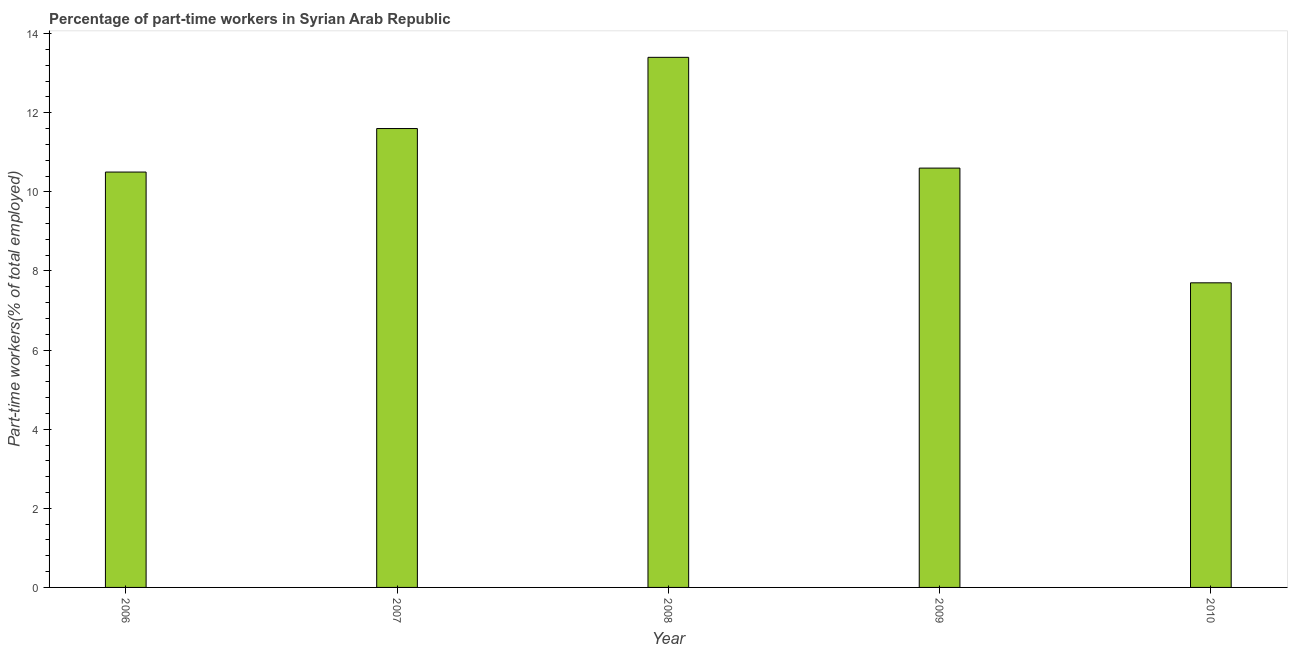Does the graph contain any zero values?
Provide a short and direct response. No. What is the title of the graph?
Give a very brief answer. Percentage of part-time workers in Syrian Arab Republic. What is the label or title of the X-axis?
Provide a short and direct response. Year. What is the label or title of the Y-axis?
Provide a succinct answer. Part-time workers(% of total employed). What is the percentage of part-time workers in 2010?
Offer a very short reply. 7.7. Across all years, what is the maximum percentage of part-time workers?
Offer a very short reply. 13.4. Across all years, what is the minimum percentage of part-time workers?
Offer a terse response. 7.7. In which year was the percentage of part-time workers maximum?
Provide a succinct answer. 2008. What is the sum of the percentage of part-time workers?
Offer a terse response. 53.8. What is the difference between the percentage of part-time workers in 2006 and 2009?
Your answer should be compact. -0.1. What is the average percentage of part-time workers per year?
Make the answer very short. 10.76. What is the median percentage of part-time workers?
Keep it short and to the point. 10.6. In how many years, is the percentage of part-time workers greater than 1.2 %?
Your answer should be compact. 5. What is the ratio of the percentage of part-time workers in 2006 to that in 2007?
Keep it short and to the point. 0.91. Is the difference between the percentage of part-time workers in 2008 and 2009 greater than the difference between any two years?
Your answer should be compact. No. In how many years, is the percentage of part-time workers greater than the average percentage of part-time workers taken over all years?
Your answer should be very brief. 2. Are all the bars in the graph horizontal?
Your answer should be compact. No. How many years are there in the graph?
Make the answer very short. 5. Are the values on the major ticks of Y-axis written in scientific E-notation?
Provide a short and direct response. No. What is the Part-time workers(% of total employed) of 2007?
Give a very brief answer. 11.6. What is the Part-time workers(% of total employed) in 2008?
Give a very brief answer. 13.4. What is the Part-time workers(% of total employed) of 2009?
Provide a short and direct response. 10.6. What is the Part-time workers(% of total employed) of 2010?
Your answer should be very brief. 7.7. What is the difference between the Part-time workers(% of total employed) in 2006 and 2007?
Your answer should be compact. -1.1. What is the difference between the Part-time workers(% of total employed) in 2006 and 2010?
Provide a succinct answer. 2.8. What is the difference between the Part-time workers(% of total employed) in 2007 and 2008?
Your answer should be compact. -1.8. What is the difference between the Part-time workers(% of total employed) in 2007 and 2010?
Give a very brief answer. 3.9. What is the difference between the Part-time workers(% of total employed) in 2008 and 2009?
Keep it short and to the point. 2.8. What is the difference between the Part-time workers(% of total employed) in 2008 and 2010?
Your answer should be very brief. 5.7. What is the difference between the Part-time workers(% of total employed) in 2009 and 2010?
Give a very brief answer. 2.9. What is the ratio of the Part-time workers(% of total employed) in 2006 to that in 2007?
Keep it short and to the point. 0.91. What is the ratio of the Part-time workers(% of total employed) in 2006 to that in 2008?
Your answer should be compact. 0.78. What is the ratio of the Part-time workers(% of total employed) in 2006 to that in 2010?
Offer a very short reply. 1.36. What is the ratio of the Part-time workers(% of total employed) in 2007 to that in 2008?
Provide a succinct answer. 0.87. What is the ratio of the Part-time workers(% of total employed) in 2007 to that in 2009?
Your response must be concise. 1.09. What is the ratio of the Part-time workers(% of total employed) in 2007 to that in 2010?
Give a very brief answer. 1.51. What is the ratio of the Part-time workers(% of total employed) in 2008 to that in 2009?
Your answer should be very brief. 1.26. What is the ratio of the Part-time workers(% of total employed) in 2008 to that in 2010?
Your answer should be compact. 1.74. What is the ratio of the Part-time workers(% of total employed) in 2009 to that in 2010?
Make the answer very short. 1.38. 